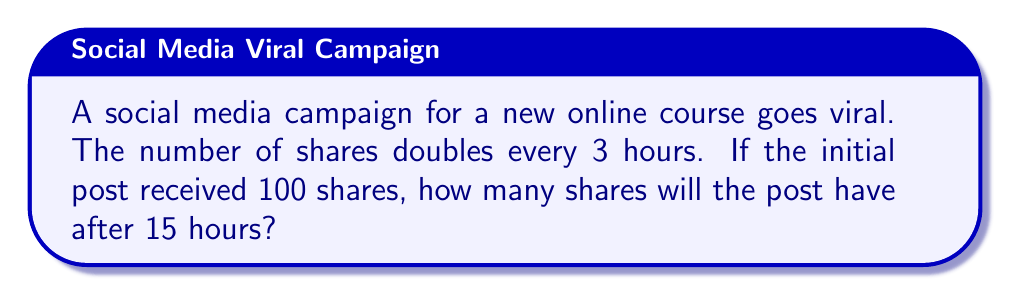What is the answer to this math problem? Let's approach this step-by-step:

1) First, we need to identify the key components of our exponential function:
   - Initial value (a): 100 shares
   - Growth factor (r): 2 (doubles every 3 hours)
   - Time (t): 15 hours

2) We use the exponential growth formula:
   $$ A = a \cdot r^n $$
   where A is the final amount, a is the initial amount, r is the growth factor, and n is the number of times the growth occurs.

3) We need to calculate n. Since the doubling occurs every 3 hours and we're looking at a 15-hour period:
   $$ n = \frac{15 \text{ hours}}{3 \text{ hours per doubling}} = 5 $$

4) Now we can plug our values into the formula:
   $$ A = 100 \cdot 2^5 $$

5) Calculate $2^5$:
   $$ 2^5 = 2 \cdot 2 \cdot 2 \cdot 2 \cdot 2 = 32 $$

6) Multiply by the initial value:
   $$ A = 100 \cdot 32 = 3200 $$

Therefore, after 15 hours, the post will have 3200 shares.
Answer: 3200 shares 